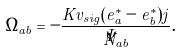Convert formula to latex. <formula><loc_0><loc_0><loc_500><loc_500>\Omega _ { a b } = - \frac { K v _ { s i g } ( e ^ { * } _ { a } - e ^ { * } _ { b } ) j } { \bar { N } _ { a b } } .</formula> 